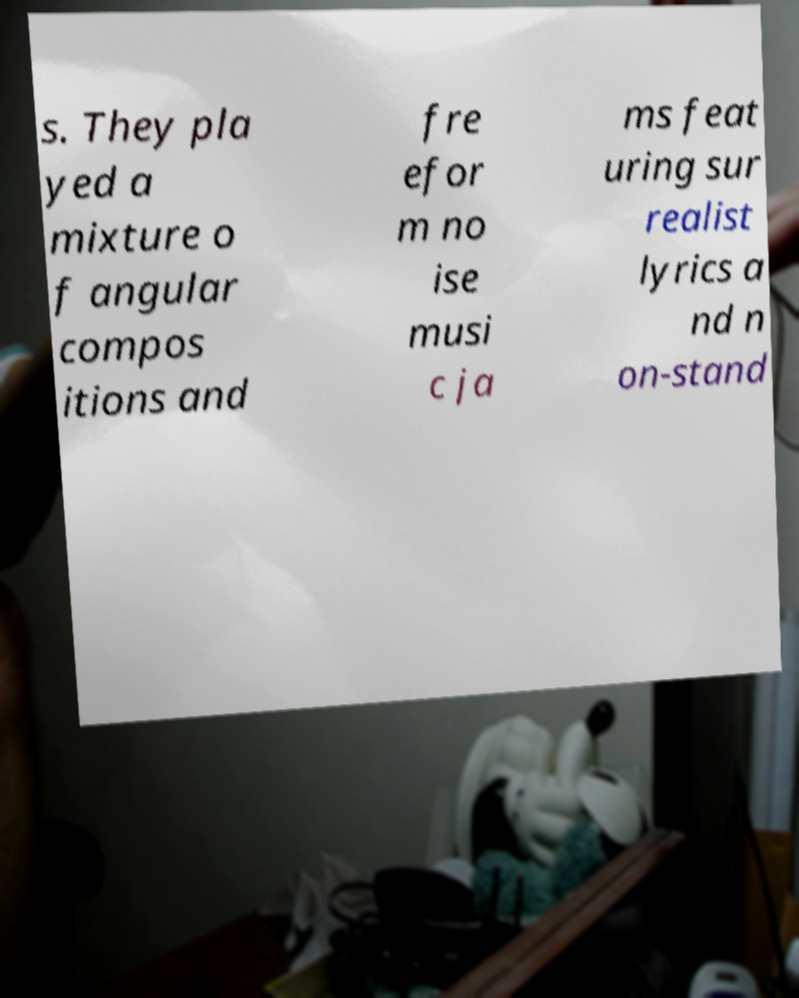Please identify and transcribe the text found in this image. s. They pla yed a mixture o f angular compos itions and fre efor m no ise musi c ja ms feat uring sur realist lyrics a nd n on-stand 